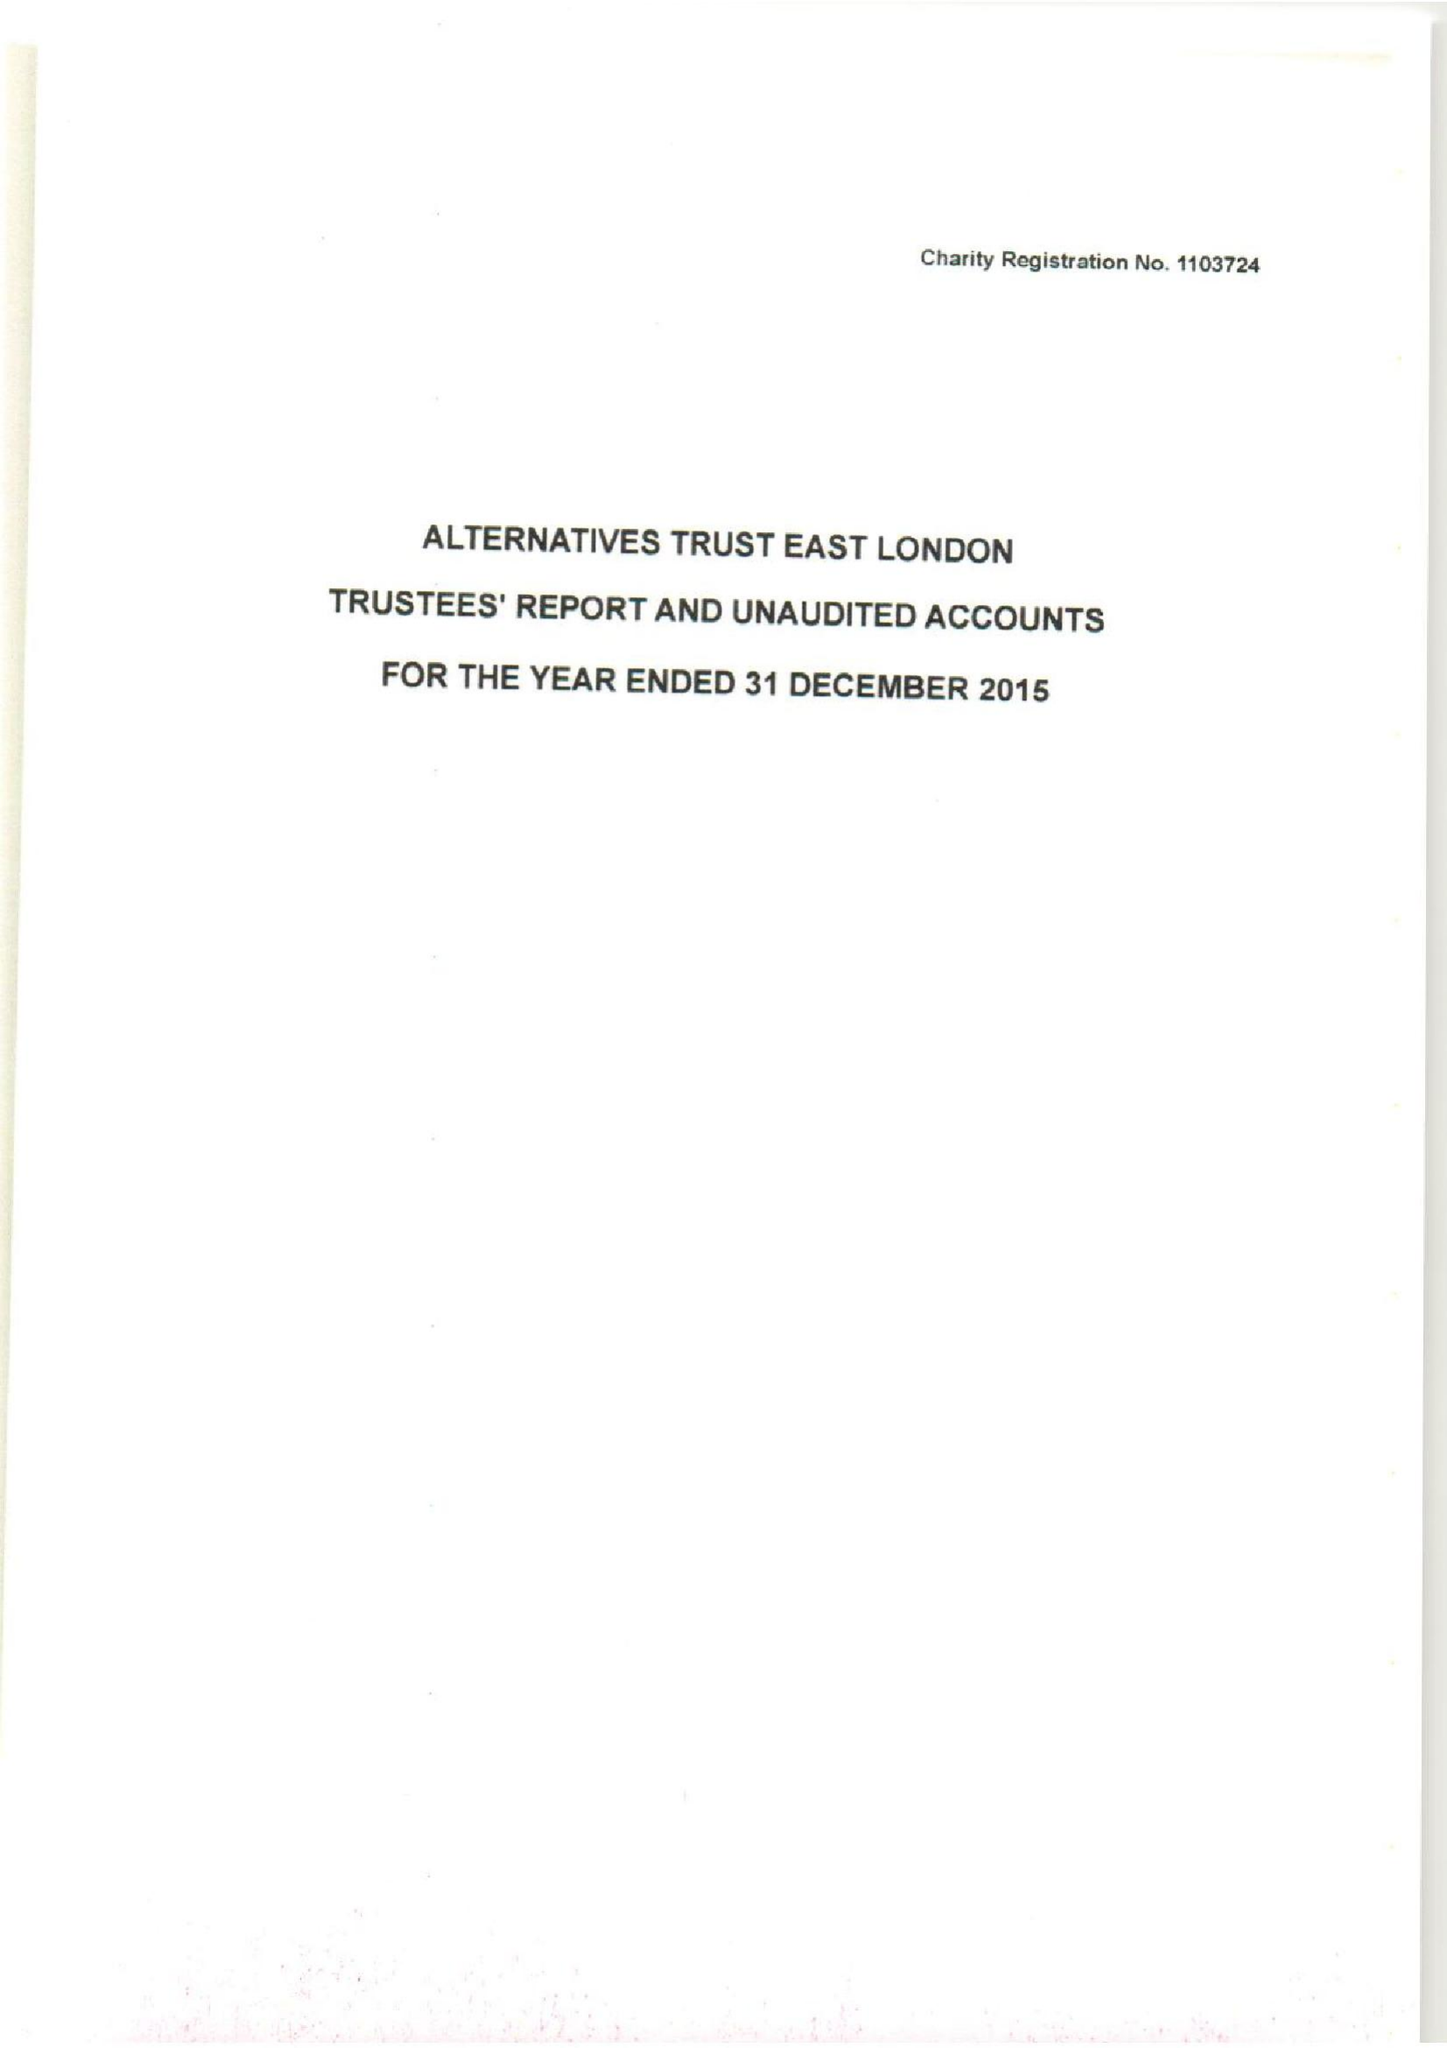What is the value for the charity_number?
Answer the question using a single word or phrase. 1103724 